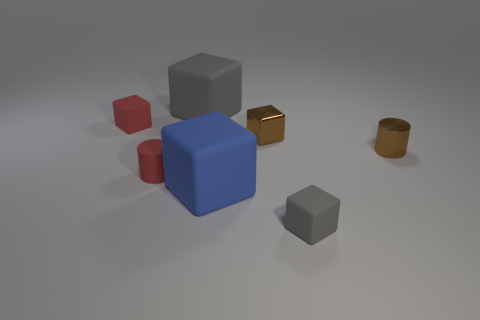Subtract 1 cubes. How many cubes are left? 4 Subtract all tiny gray rubber cubes. How many cubes are left? 4 Subtract all red cubes. How many cubes are left? 4 Subtract all green cubes. Subtract all yellow cylinders. How many cubes are left? 5 Add 2 gray matte cubes. How many objects exist? 9 Subtract all cylinders. How many objects are left? 5 Subtract 0 green balls. How many objects are left? 7 Subtract all yellow shiny cylinders. Subtract all brown metal cubes. How many objects are left? 6 Add 4 tiny shiny cylinders. How many tiny shiny cylinders are left? 5 Add 5 big things. How many big things exist? 7 